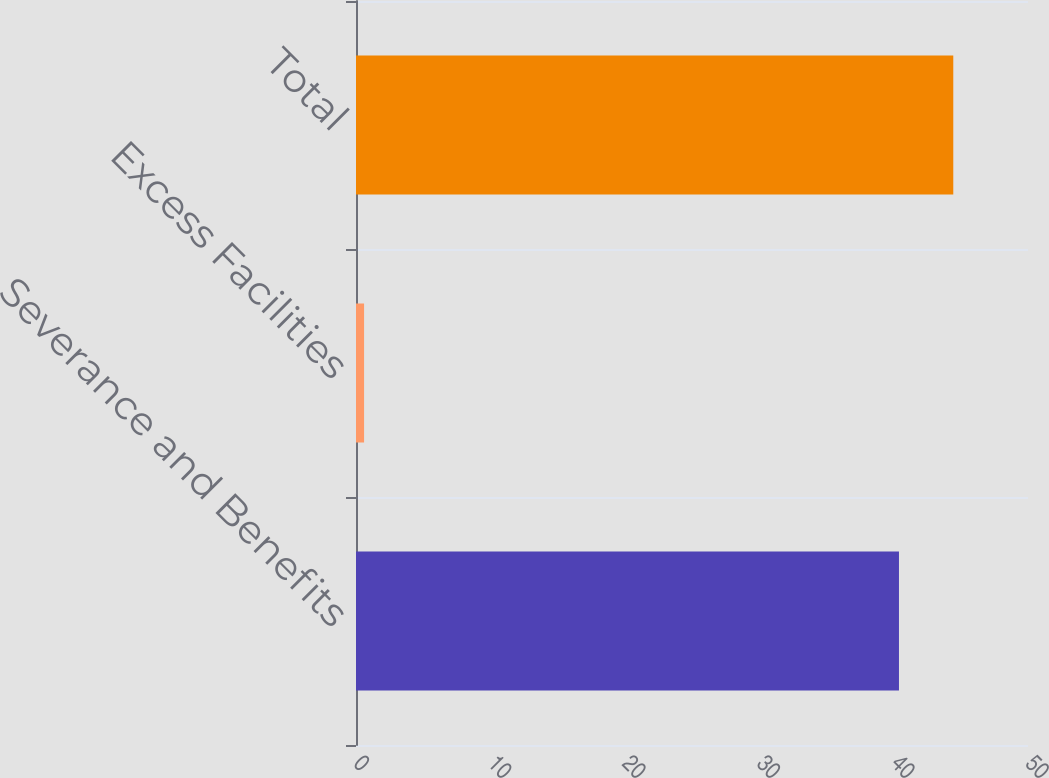<chart> <loc_0><loc_0><loc_500><loc_500><bar_chart><fcel>Severance and Benefits<fcel>Excess Facilities<fcel>Total<nl><fcel>40.4<fcel>0.6<fcel>44.44<nl></chart> 